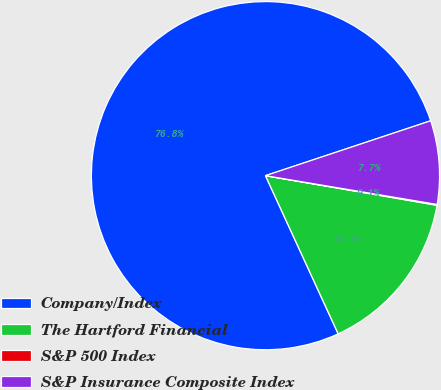<chart> <loc_0><loc_0><loc_500><loc_500><pie_chart><fcel>Company/Index<fcel>The Hartford Financial<fcel>S&P 500 Index<fcel>S&P Insurance Composite Index<nl><fcel>76.76%<fcel>15.42%<fcel>0.08%<fcel>7.75%<nl></chart> 